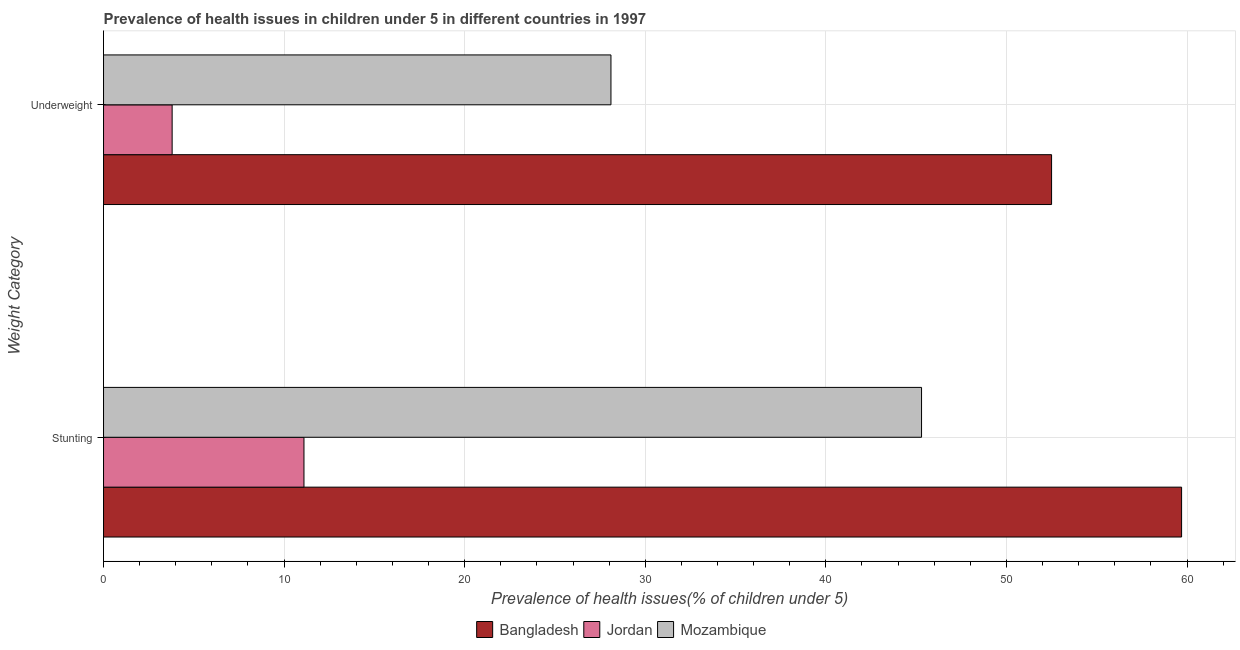How many different coloured bars are there?
Offer a very short reply. 3. How many groups of bars are there?
Offer a very short reply. 2. How many bars are there on the 2nd tick from the top?
Keep it short and to the point. 3. What is the label of the 1st group of bars from the top?
Provide a short and direct response. Underweight. What is the percentage of stunted children in Mozambique?
Make the answer very short. 45.3. Across all countries, what is the maximum percentage of underweight children?
Give a very brief answer. 52.5. Across all countries, what is the minimum percentage of underweight children?
Provide a short and direct response. 3.8. In which country was the percentage of stunted children maximum?
Make the answer very short. Bangladesh. In which country was the percentage of stunted children minimum?
Keep it short and to the point. Jordan. What is the total percentage of underweight children in the graph?
Offer a terse response. 84.4. What is the difference between the percentage of stunted children in Mozambique and that in Bangladesh?
Your answer should be compact. -14.4. What is the difference between the percentage of stunted children in Mozambique and the percentage of underweight children in Jordan?
Your answer should be very brief. 41.5. What is the average percentage of stunted children per country?
Your answer should be compact. 38.7. What is the difference between the percentage of underweight children and percentage of stunted children in Mozambique?
Keep it short and to the point. -17.2. In how many countries, is the percentage of stunted children greater than 42 %?
Give a very brief answer. 2. What is the ratio of the percentage of stunted children in Jordan to that in Mozambique?
Make the answer very short. 0.25. In how many countries, is the percentage of stunted children greater than the average percentage of stunted children taken over all countries?
Make the answer very short. 2. What does the 1st bar from the top in Underweight represents?
Offer a terse response. Mozambique. What does the 2nd bar from the bottom in Stunting represents?
Provide a short and direct response. Jordan. How many bars are there?
Your response must be concise. 6. Where does the legend appear in the graph?
Provide a short and direct response. Bottom center. How many legend labels are there?
Ensure brevity in your answer.  3. What is the title of the graph?
Give a very brief answer. Prevalence of health issues in children under 5 in different countries in 1997. What is the label or title of the X-axis?
Provide a succinct answer. Prevalence of health issues(% of children under 5). What is the label or title of the Y-axis?
Provide a succinct answer. Weight Category. What is the Prevalence of health issues(% of children under 5) of Bangladesh in Stunting?
Provide a succinct answer. 59.7. What is the Prevalence of health issues(% of children under 5) in Jordan in Stunting?
Your answer should be compact. 11.1. What is the Prevalence of health issues(% of children under 5) of Mozambique in Stunting?
Provide a short and direct response. 45.3. What is the Prevalence of health issues(% of children under 5) in Bangladesh in Underweight?
Provide a short and direct response. 52.5. What is the Prevalence of health issues(% of children under 5) of Jordan in Underweight?
Provide a short and direct response. 3.8. What is the Prevalence of health issues(% of children under 5) of Mozambique in Underweight?
Provide a succinct answer. 28.1. Across all Weight Category, what is the maximum Prevalence of health issues(% of children under 5) of Bangladesh?
Ensure brevity in your answer.  59.7. Across all Weight Category, what is the maximum Prevalence of health issues(% of children under 5) of Jordan?
Make the answer very short. 11.1. Across all Weight Category, what is the maximum Prevalence of health issues(% of children under 5) in Mozambique?
Give a very brief answer. 45.3. Across all Weight Category, what is the minimum Prevalence of health issues(% of children under 5) of Bangladesh?
Make the answer very short. 52.5. Across all Weight Category, what is the minimum Prevalence of health issues(% of children under 5) in Jordan?
Your answer should be very brief. 3.8. Across all Weight Category, what is the minimum Prevalence of health issues(% of children under 5) in Mozambique?
Make the answer very short. 28.1. What is the total Prevalence of health issues(% of children under 5) of Bangladesh in the graph?
Keep it short and to the point. 112.2. What is the total Prevalence of health issues(% of children under 5) of Jordan in the graph?
Your answer should be very brief. 14.9. What is the total Prevalence of health issues(% of children under 5) of Mozambique in the graph?
Provide a succinct answer. 73.4. What is the difference between the Prevalence of health issues(% of children under 5) of Bangladesh in Stunting and that in Underweight?
Make the answer very short. 7.2. What is the difference between the Prevalence of health issues(% of children under 5) of Bangladesh in Stunting and the Prevalence of health issues(% of children under 5) of Jordan in Underweight?
Keep it short and to the point. 55.9. What is the difference between the Prevalence of health issues(% of children under 5) of Bangladesh in Stunting and the Prevalence of health issues(% of children under 5) of Mozambique in Underweight?
Provide a succinct answer. 31.6. What is the average Prevalence of health issues(% of children under 5) in Bangladesh per Weight Category?
Ensure brevity in your answer.  56.1. What is the average Prevalence of health issues(% of children under 5) of Jordan per Weight Category?
Ensure brevity in your answer.  7.45. What is the average Prevalence of health issues(% of children under 5) in Mozambique per Weight Category?
Ensure brevity in your answer.  36.7. What is the difference between the Prevalence of health issues(% of children under 5) of Bangladesh and Prevalence of health issues(% of children under 5) of Jordan in Stunting?
Ensure brevity in your answer.  48.6. What is the difference between the Prevalence of health issues(% of children under 5) of Bangladesh and Prevalence of health issues(% of children under 5) of Mozambique in Stunting?
Make the answer very short. 14.4. What is the difference between the Prevalence of health issues(% of children under 5) in Jordan and Prevalence of health issues(% of children under 5) in Mozambique in Stunting?
Offer a terse response. -34.2. What is the difference between the Prevalence of health issues(% of children under 5) in Bangladesh and Prevalence of health issues(% of children under 5) in Jordan in Underweight?
Give a very brief answer. 48.7. What is the difference between the Prevalence of health issues(% of children under 5) in Bangladesh and Prevalence of health issues(% of children under 5) in Mozambique in Underweight?
Provide a short and direct response. 24.4. What is the difference between the Prevalence of health issues(% of children under 5) in Jordan and Prevalence of health issues(% of children under 5) in Mozambique in Underweight?
Ensure brevity in your answer.  -24.3. What is the ratio of the Prevalence of health issues(% of children under 5) in Bangladesh in Stunting to that in Underweight?
Offer a very short reply. 1.14. What is the ratio of the Prevalence of health issues(% of children under 5) of Jordan in Stunting to that in Underweight?
Your response must be concise. 2.92. What is the ratio of the Prevalence of health issues(% of children under 5) of Mozambique in Stunting to that in Underweight?
Your answer should be compact. 1.61. What is the difference between the highest and the second highest Prevalence of health issues(% of children under 5) in Jordan?
Your response must be concise. 7.3. What is the difference between the highest and the second highest Prevalence of health issues(% of children under 5) of Mozambique?
Ensure brevity in your answer.  17.2. What is the difference between the highest and the lowest Prevalence of health issues(% of children under 5) of Jordan?
Your answer should be very brief. 7.3. 